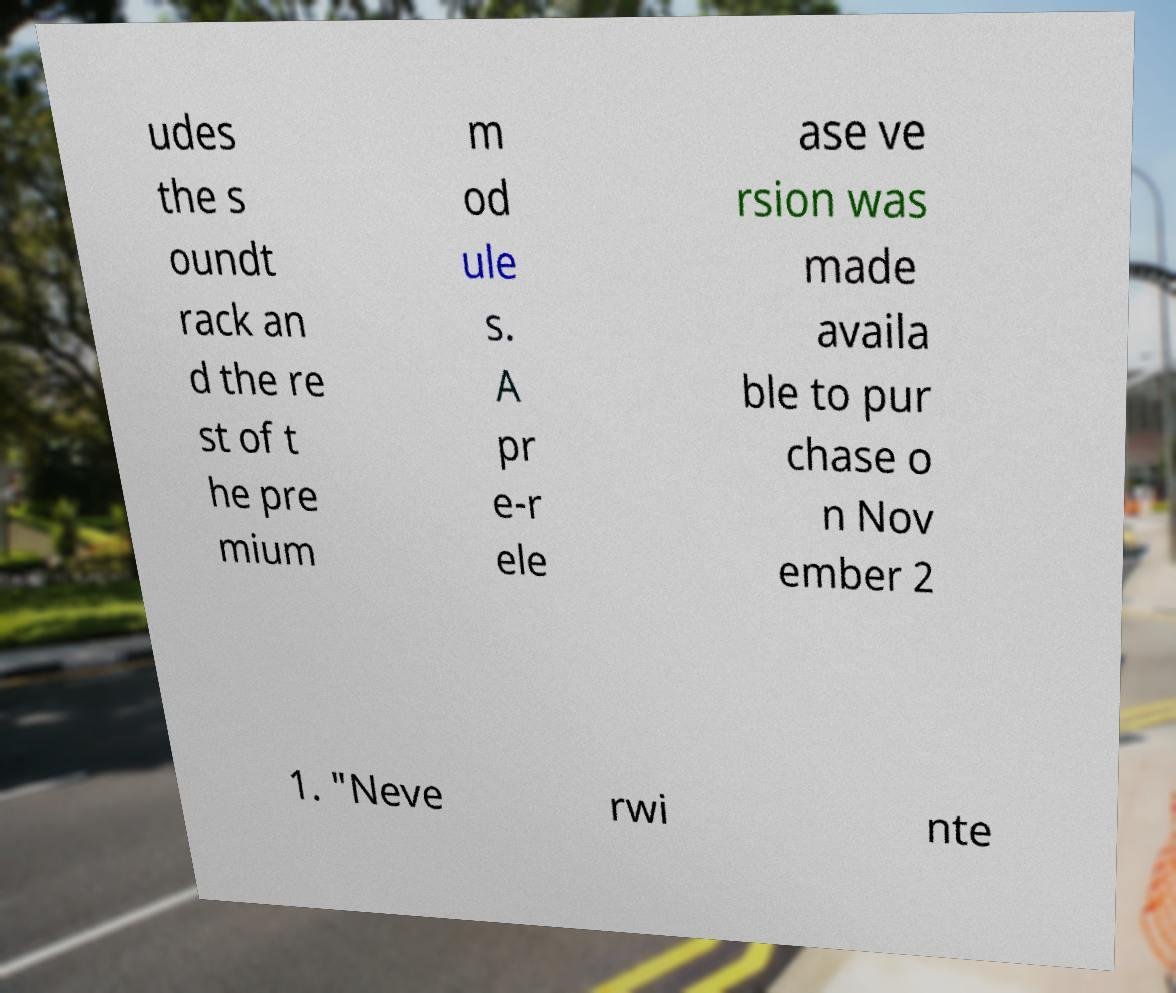Can you accurately transcribe the text from the provided image for me? udes the s oundt rack an d the re st of t he pre mium m od ule s. A pr e-r ele ase ve rsion was made availa ble to pur chase o n Nov ember 2 1. "Neve rwi nte 